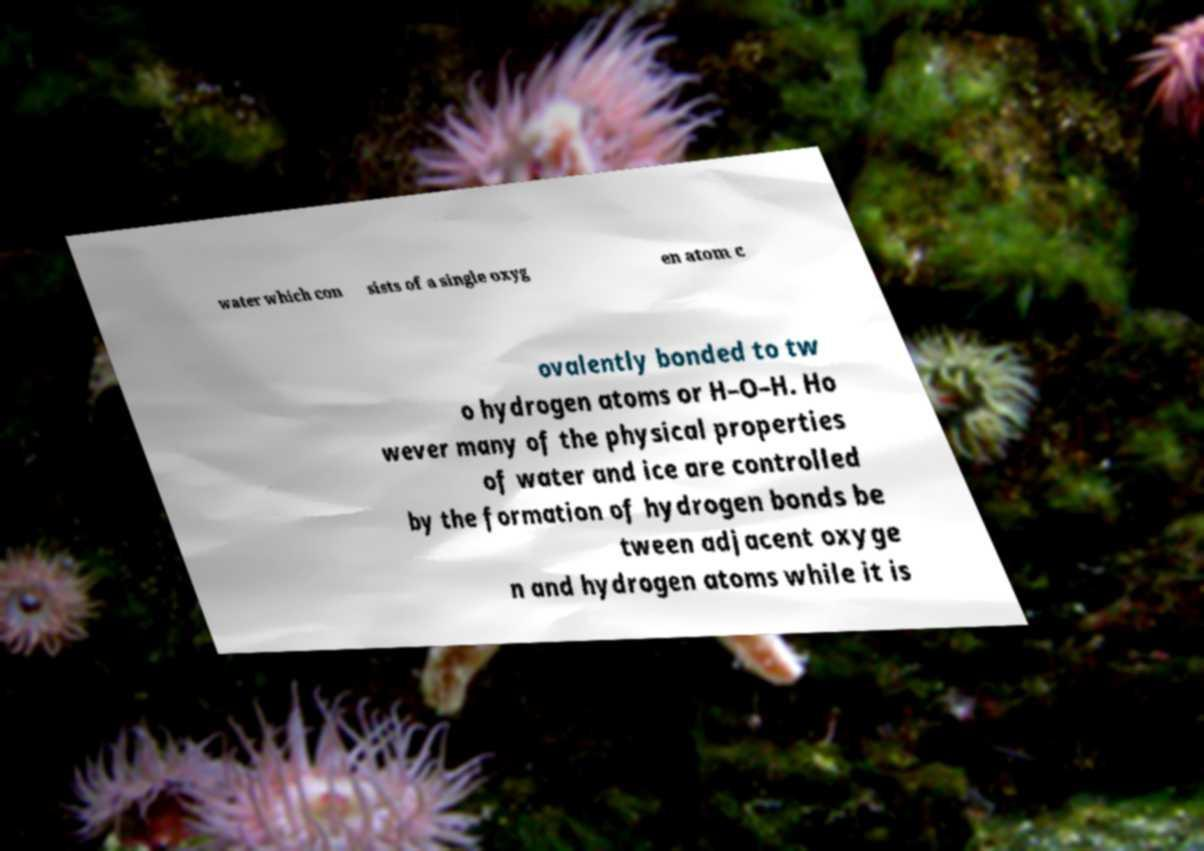There's text embedded in this image that I need extracted. Can you transcribe it verbatim? water which con sists of a single oxyg en atom c ovalently bonded to tw o hydrogen atoms or H–O–H. Ho wever many of the physical properties of water and ice are controlled by the formation of hydrogen bonds be tween adjacent oxyge n and hydrogen atoms while it is 